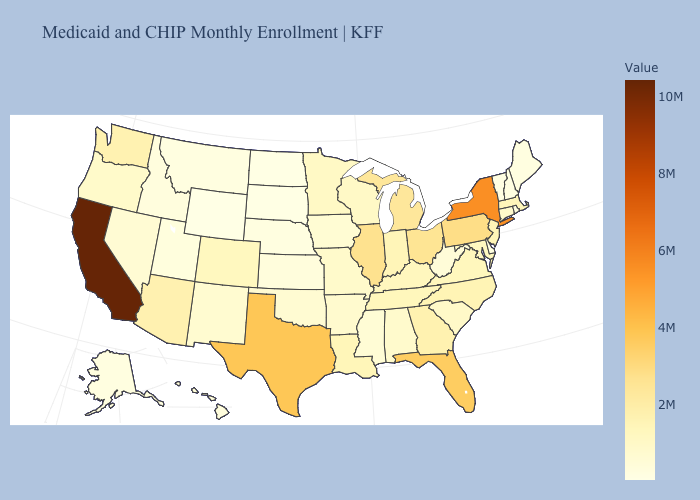Does California have the highest value in the USA?
Write a very short answer. Yes. Among the states that border South Dakota , does Minnesota have the highest value?
Be succinct. Yes. Does Wisconsin have the lowest value in the MidWest?
Be succinct. No. Does the map have missing data?
Write a very short answer. No. Which states have the highest value in the USA?
Give a very brief answer. California. 